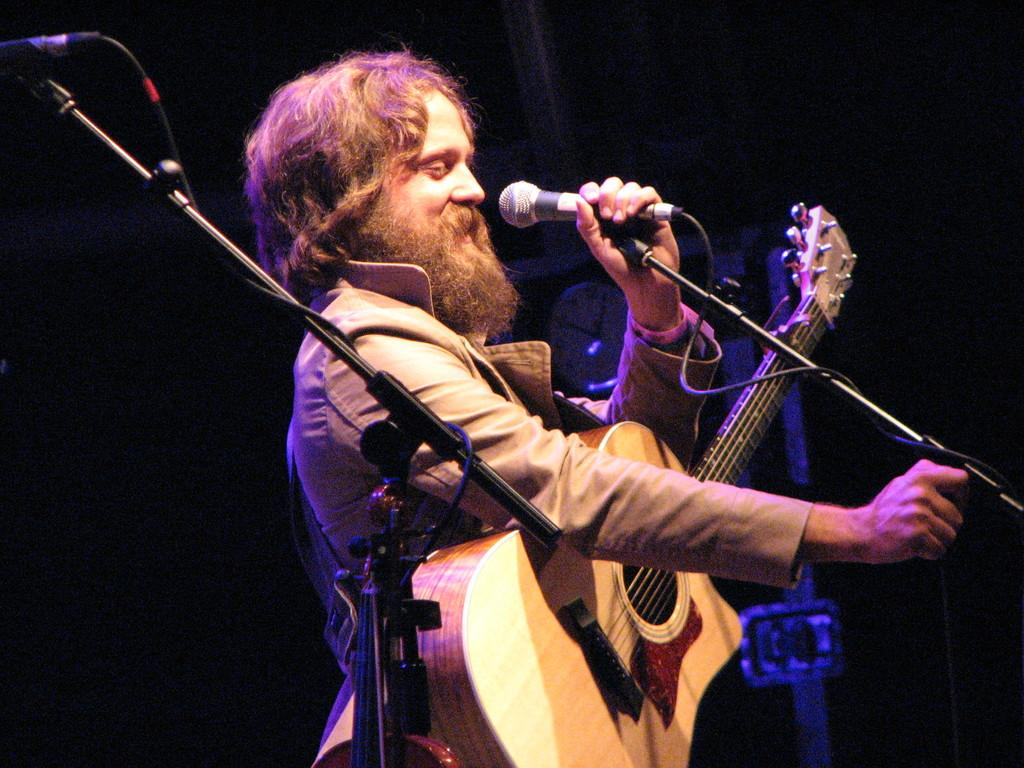Who is the main subject in the image? There is a man in the image. What is the man holding in his hands? The man is holding a guitar and a microphone in his hands. What is the man doing in the image? The man is speaking. What type of tray is the man using to balance the ball in the image? There is no tray or ball present in the image; the man is holding a guitar and a microphone. 